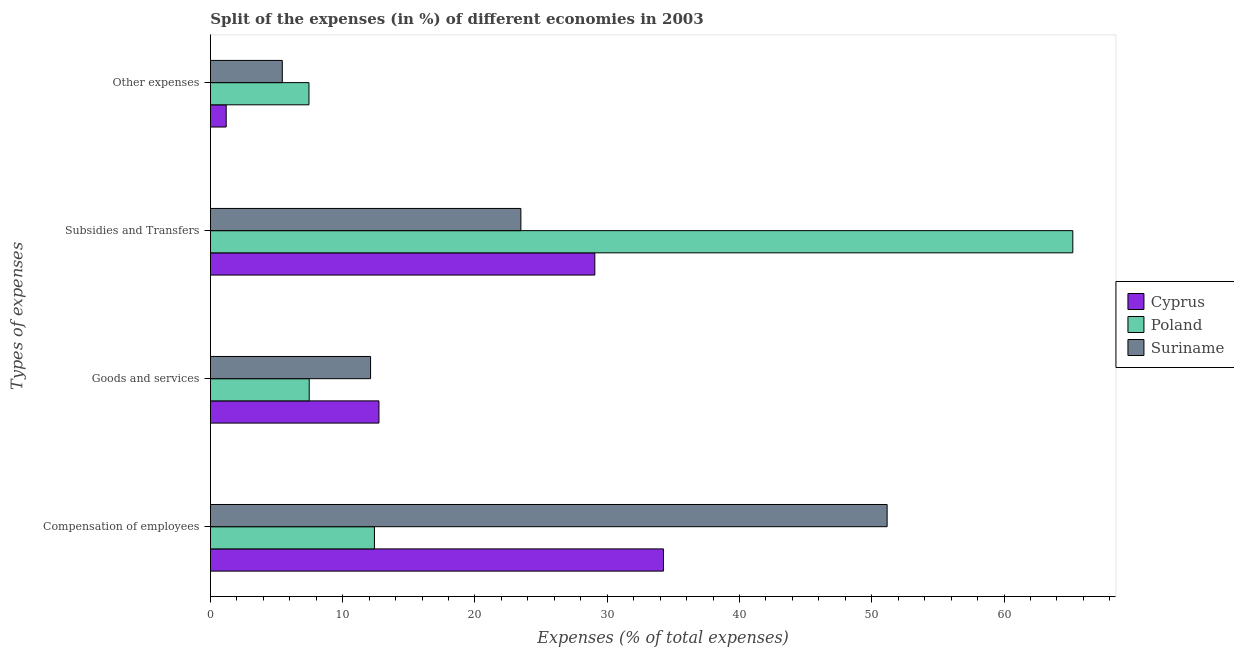How many different coloured bars are there?
Your response must be concise. 3. How many groups of bars are there?
Your answer should be compact. 4. Are the number of bars per tick equal to the number of legend labels?
Make the answer very short. Yes. Are the number of bars on each tick of the Y-axis equal?
Keep it short and to the point. Yes. How many bars are there on the 1st tick from the top?
Keep it short and to the point. 3. What is the label of the 2nd group of bars from the top?
Offer a very short reply. Subsidies and Transfers. What is the percentage of amount spent on goods and services in Poland?
Provide a succinct answer. 7.47. Across all countries, what is the maximum percentage of amount spent on goods and services?
Your answer should be compact. 12.74. Across all countries, what is the minimum percentage of amount spent on goods and services?
Give a very brief answer. 7.47. In which country was the percentage of amount spent on compensation of employees maximum?
Your response must be concise. Suriname. In which country was the percentage of amount spent on subsidies minimum?
Your response must be concise. Suriname. What is the total percentage of amount spent on compensation of employees in the graph?
Offer a terse response. 97.81. What is the difference between the percentage of amount spent on other expenses in Cyprus and that in Poland?
Offer a very short reply. -6.26. What is the difference between the percentage of amount spent on compensation of employees in Cyprus and the percentage of amount spent on subsidies in Suriname?
Provide a short and direct response. 10.78. What is the average percentage of amount spent on other expenses per country?
Make the answer very short. 4.69. What is the difference between the percentage of amount spent on compensation of employees and percentage of amount spent on other expenses in Suriname?
Provide a succinct answer. 45.72. In how many countries, is the percentage of amount spent on other expenses greater than 22 %?
Make the answer very short. 0. What is the ratio of the percentage of amount spent on other expenses in Poland to that in Suriname?
Offer a very short reply. 1.37. What is the difference between the highest and the second highest percentage of amount spent on goods and services?
Provide a succinct answer. 0.63. What is the difference between the highest and the lowest percentage of amount spent on subsidies?
Your response must be concise. 41.72. Is the sum of the percentage of amount spent on compensation of employees in Cyprus and Suriname greater than the maximum percentage of amount spent on subsidies across all countries?
Your answer should be compact. Yes. What does the 3rd bar from the top in Compensation of employees represents?
Your response must be concise. Cyprus. What does the 2nd bar from the bottom in Subsidies and Transfers represents?
Offer a very short reply. Poland. Is it the case that in every country, the sum of the percentage of amount spent on compensation of employees and percentage of amount spent on goods and services is greater than the percentage of amount spent on subsidies?
Offer a terse response. No. How many countries are there in the graph?
Your response must be concise. 3. Does the graph contain grids?
Ensure brevity in your answer.  No. Where does the legend appear in the graph?
Your answer should be compact. Center right. How many legend labels are there?
Make the answer very short. 3. What is the title of the graph?
Give a very brief answer. Split of the expenses (in %) of different economies in 2003. Does "Jamaica" appear as one of the legend labels in the graph?
Ensure brevity in your answer.  No. What is the label or title of the X-axis?
Your answer should be very brief. Expenses (% of total expenses). What is the label or title of the Y-axis?
Give a very brief answer. Types of expenses. What is the Expenses (% of total expenses) in Cyprus in Compensation of employees?
Offer a very short reply. 34.25. What is the Expenses (% of total expenses) in Poland in Compensation of employees?
Keep it short and to the point. 12.4. What is the Expenses (% of total expenses) in Suriname in Compensation of employees?
Your answer should be very brief. 51.16. What is the Expenses (% of total expenses) of Cyprus in Goods and services?
Your answer should be very brief. 12.74. What is the Expenses (% of total expenses) in Poland in Goods and services?
Your answer should be very brief. 7.47. What is the Expenses (% of total expenses) in Suriname in Goods and services?
Offer a very short reply. 12.11. What is the Expenses (% of total expenses) of Cyprus in Subsidies and Transfers?
Offer a terse response. 29.06. What is the Expenses (% of total expenses) in Poland in Subsidies and Transfers?
Keep it short and to the point. 65.2. What is the Expenses (% of total expenses) of Suriname in Subsidies and Transfers?
Ensure brevity in your answer.  23.47. What is the Expenses (% of total expenses) of Cyprus in Other expenses?
Make the answer very short. 1.2. What is the Expenses (% of total expenses) in Poland in Other expenses?
Provide a succinct answer. 7.45. What is the Expenses (% of total expenses) in Suriname in Other expenses?
Provide a short and direct response. 5.44. Across all Types of expenses, what is the maximum Expenses (% of total expenses) of Cyprus?
Your answer should be very brief. 34.25. Across all Types of expenses, what is the maximum Expenses (% of total expenses) in Poland?
Provide a succinct answer. 65.2. Across all Types of expenses, what is the maximum Expenses (% of total expenses) of Suriname?
Make the answer very short. 51.16. Across all Types of expenses, what is the minimum Expenses (% of total expenses) of Cyprus?
Offer a very short reply. 1.2. Across all Types of expenses, what is the minimum Expenses (% of total expenses) of Poland?
Your response must be concise. 7.45. Across all Types of expenses, what is the minimum Expenses (% of total expenses) in Suriname?
Your response must be concise. 5.44. What is the total Expenses (% of total expenses) of Cyprus in the graph?
Offer a terse response. 77.25. What is the total Expenses (% of total expenses) in Poland in the graph?
Ensure brevity in your answer.  92.52. What is the total Expenses (% of total expenses) in Suriname in the graph?
Your answer should be compact. 92.18. What is the difference between the Expenses (% of total expenses) of Cyprus in Compensation of employees and that in Goods and services?
Offer a very short reply. 21.51. What is the difference between the Expenses (% of total expenses) of Poland in Compensation of employees and that in Goods and services?
Provide a succinct answer. 4.93. What is the difference between the Expenses (% of total expenses) of Suriname in Compensation of employees and that in Goods and services?
Your response must be concise. 39.05. What is the difference between the Expenses (% of total expenses) in Cyprus in Compensation of employees and that in Subsidies and Transfers?
Make the answer very short. 5.19. What is the difference between the Expenses (% of total expenses) in Poland in Compensation of employees and that in Subsidies and Transfers?
Your answer should be compact. -52.79. What is the difference between the Expenses (% of total expenses) of Suriname in Compensation of employees and that in Subsidies and Transfers?
Ensure brevity in your answer.  27.69. What is the difference between the Expenses (% of total expenses) of Cyprus in Compensation of employees and that in Other expenses?
Your answer should be very brief. 33.05. What is the difference between the Expenses (% of total expenses) of Poland in Compensation of employees and that in Other expenses?
Your response must be concise. 4.95. What is the difference between the Expenses (% of total expenses) of Suriname in Compensation of employees and that in Other expenses?
Offer a very short reply. 45.72. What is the difference between the Expenses (% of total expenses) in Cyprus in Goods and services and that in Subsidies and Transfers?
Make the answer very short. -16.32. What is the difference between the Expenses (% of total expenses) of Poland in Goods and services and that in Subsidies and Transfers?
Give a very brief answer. -57.72. What is the difference between the Expenses (% of total expenses) in Suriname in Goods and services and that in Subsidies and Transfers?
Make the answer very short. -11.36. What is the difference between the Expenses (% of total expenses) of Cyprus in Goods and services and that in Other expenses?
Provide a short and direct response. 11.55. What is the difference between the Expenses (% of total expenses) in Poland in Goods and services and that in Other expenses?
Offer a terse response. 0.02. What is the difference between the Expenses (% of total expenses) in Suriname in Goods and services and that in Other expenses?
Your answer should be compact. 6.67. What is the difference between the Expenses (% of total expenses) of Cyprus in Subsidies and Transfers and that in Other expenses?
Give a very brief answer. 27.87. What is the difference between the Expenses (% of total expenses) in Poland in Subsidies and Transfers and that in Other expenses?
Ensure brevity in your answer.  57.74. What is the difference between the Expenses (% of total expenses) of Suriname in Subsidies and Transfers and that in Other expenses?
Your answer should be very brief. 18.04. What is the difference between the Expenses (% of total expenses) in Cyprus in Compensation of employees and the Expenses (% of total expenses) in Poland in Goods and services?
Ensure brevity in your answer.  26.78. What is the difference between the Expenses (% of total expenses) in Cyprus in Compensation of employees and the Expenses (% of total expenses) in Suriname in Goods and services?
Offer a very short reply. 22.14. What is the difference between the Expenses (% of total expenses) in Poland in Compensation of employees and the Expenses (% of total expenses) in Suriname in Goods and services?
Keep it short and to the point. 0.29. What is the difference between the Expenses (% of total expenses) of Cyprus in Compensation of employees and the Expenses (% of total expenses) of Poland in Subsidies and Transfers?
Your response must be concise. -30.95. What is the difference between the Expenses (% of total expenses) in Cyprus in Compensation of employees and the Expenses (% of total expenses) in Suriname in Subsidies and Transfers?
Make the answer very short. 10.78. What is the difference between the Expenses (% of total expenses) of Poland in Compensation of employees and the Expenses (% of total expenses) of Suriname in Subsidies and Transfers?
Ensure brevity in your answer.  -11.07. What is the difference between the Expenses (% of total expenses) of Cyprus in Compensation of employees and the Expenses (% of total expenses) of Poland in Other expenses?
Your response must be concise. 26.8. What is the difference between the Expenses (% of total expenses) in Cyprus in Compensation of employees and the Expenses (% of total expenses) in Suriname in Other expenses?
Your answer should be compact. 28.81. What is the difference between the Expenses (% of total expenses) in Poland in Compensation of employees and the Expenses (% of total expenses) in Suriname in Other expenses?
Give a very brief answer. 6.97. What is the difference between the Expenses (% of total expenses) of Cyprus in Goods and services and the Expenses (% of total expenses) of Poland in Subsidies and Transfers?
Provide a succinct answer. -52.45. What is the difference between the Expenses (% of total expenses) of Cyprus in Goods and services and the Expenses (% of total expenses) of Suriname in Subsidies and Transfers?
Provide a short and direct response. -10.73. What is the difference between the Expenses (% of total expenses) in Poland in Goods and services and the Expenses (% of total expenses) in Suriname in Subsidies and Transfers?
Provide a short and direct response. -16. What is the difference between the Expenses (% of total expenses) in Cyprus in Goods and services and the Expenses (% of total expenses) in Poland in Other expenses?
Ensure brevity in your answer.  5.29. What is the difference between the Expenses (% of total expenses) in Cyprus in Goods and services and the Expenses (% of total expenses) in Suriname in Other expenses?
Your answer should be compact. 7.31. What is the difference between the Expenses (% of total expenses) of Poland in Goods and services and the Expenses (% of total expenses) of Suriname in Other expenses?
Your response must be concise. 2.04. What is the difference between the Expenses (% of total expenses) of Cyprus in Subsidies and Transfers and the Expenses (% of total expenses) of Poland in Other expenses?
Provide a short and direct response. 21.61. What is the difference between the Expenses (% of total expenses) of Cyprus in Subsidies and Transfers and the Expenses (% of total expenses) of Suriname in Other expenses?
Ensure brevity in your answer.  23.63. What is the difference between the Expenses (% of total expenses) of Poland in Subsidies and Transfers and the Expenses (% of total expenses) of Suriname in Other expenses?
Provide a succinct answer. 59.76. What is the average Expenses (% of total expenses) of Cyprus per Types of expenses?
Offer a very short reply. 19.31. What is the average Expenses (% of total expenses) of Poland per Types of expenses?
Your answer should be very brief. 23.13. What is the average Expenses (% of total expenses) in Suriname per Types of expenses?
Give a very brief answer. 23.04. What is the difference between the Expenses (% of total expenses) in Cyprus and Expenses (% of total expenses) in Poland in Compensation of employees?
Your response must be concise. 21.85. What is the difference between the Expenses (% of total expenses) of Cyprus and Expenses (% of total expenses) of Suriname in Compensation of employees?
Make the answer very short. -16.91. What is the difference between the Expenses (% of total expenses) of Poland and Expenses (% of total expenses) of Suriname in Compensation of employees?
Keep it short and to the point. -38.76. What is the difference between the Expenses (% of total expenses) of Cyprus and Expenses (% of total expenses) of Poland in Goods and services?
Your answer should be compact. 5.27. What is the difference between the Expenses (% of total expenses) in Cyprus and Expenses (% of total expenses) in Suriname in Goods and services?
Provide a short and direct response. 0.63. What is the difference between the Expenses (% of total expenses) of Poland and Expenses (% of total expenses) of Suriname in Goods and services?
Provide a succinct answer. -4.64. What is the difference between the Expenses (% of total expenses) of Cyprus and Expenses (% of total expenses) of Poland in Subsidies and Transfers?
Offer a very short reply. -36.13. What is the difference between the Expenses (% of total expenses) in Cyprus and Expenses (% of total expenses) in Suriname in Subsidies and Transfers?
Provide a succinct answer. 5.59. What is the difference between the Expenses (% of total expenses) of Poland and Expenses (% of total expenses) of Suriname in Subsidies and Transfers?
Offer a terse response. 41.72. What is the difference between the Expenses (% of total expenses) of Cyprus and Expenses (% of total expenses) of Poland in Other expenses?
Your answer should be very brief. -6.26. What is the difference between the Expenses (% of total expenses) of Cyprus and Expenses (% of total expenses) of Suriname in Other expenses?
Give a very brief answer. -4.24. What is the difference between the Expenses (% of total expenses) in Poland and Expenses (% of total expenses) in Suriname in Other expenses?
Your response must be concise. 2.02. What is the ratio of the Expenses (% of total expenses) in Cyprus in Compensation of employees to that in Goods and services?
Keep it short and to the point. 2.69. What is the ratio of the Expenses (% of total expenses) in Poland in Compensation of employees to that in Goods and services?
Offer a very short reply. 1.66. What is the ratio of the Expenses (% of total expenses) in Suriname in Compensation of employees to that in Goods and services?
Make the answer very short. 4.22. What is the ratio of the Expenses (% of total expenses) in Cyprus in Compensation of employees to that in Subsidies and Transfers?
Offer a terse response. 1.18. What is the ratio of the Expenses (% of total expenses) in Poland in Compensation of employees to that in Subsidies and Transfers?
Ensure brevity in your answer.  0.19. What is the ratio of the Expenses (% of total expenses) of Suriname in Compensation of employees to that in Subsidies and Transfers?
Provide a succinct answer. 2.18. What is the ratio of the Expenses (% of total expenses) in Cyprus in Compensation of employees to that in Other expenses?
Provide a succinct answer. 28.65. What is the ratio of the Expenses (% of total expenses) in Poland in Compensation of employees to that in Other expenses?
Provide a succinct answer. 1.66. What is the ratio of the Expenses (% of total expenses) of Suriname in Compensation of employees to that in Other expenses?
Your answer should be very brief. 9.41. What is the ratio of the Expenses (% of total expenses) of Cyprus in Goods and services to that in Subsidies and Transfers?
Give a very brief answer. 0.44. What is the ratio of the Expenses (% of total expenses) in Poland in Goods and services to that in Subsidies and Transfers?
Keep it short and to the point. 0.11. What is the ratio of the Expenses (% of total expenses) of Suriname in Goods and services to that in Subsidies and Transfers?
Make the answer very short. 0.52. What is the ratio of the Expenses (% of total expenses) of Cyprus in Goods and services to that in Other expenses?
Keep it short and to the point. 10.66. What is the ratio of the Expenses (% of total expenses) of Poland in Goods and services to that in Other expenses?
Give a very brief answer. 1. What is the ratio of the Expenses (% of total expenses) of Suriname in Goods and services to that in Other expenses?
Ensure brevity in your answer.  2.23. What is the ratio of the Expenses (% of total expenses) in Cyprus in Subsidies and Transfers to that in Other expenses?
Provide a short and direct response. 24.31. What is the ratio of the Expenses (% of total expenses) in Poland in Subsidies and Transfers to that in Other expenses?
Your response must be concise. 8.75. What is the ratio of the Expenses (% of total expenses) of Suriname in Subsidies and Transfers to that in Other expenses?
Offer a very short reply. 4.32. What is the difference between the highest and the second highest Expenses (% of total expenses) of Cyprus?
Your answer should be compact. 5.19. What is the difference between the highest and the second highest Expenses (% of total expenses) in Poland?
Make the answer very short. 52.79. What is the difference between the highest and the second highest Expenses (% of total expenses) in Suriname?
Make the answer very short. 27.69. What is the difference between the highest and the lowest Expenses (% of total expenses) in Cyprus?
Offer a terse response. 33.05. What is the difference between the highest and the lowest Expenses (% of total expenses) in Poland?
Provide a succinct answer. 57.74. What is the difference between the highest and the lowest Expenses (% of total expenses) in Suriname?
Give a very brief answer. 45.72. 